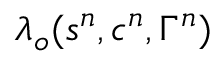Convert formula to latex. <formula><loc_0><loc_0><loc_500><loc_500>{ \lambda } _ { o } ( s ^ { n } , c ^ { n } , \Gamma ^ { n } )</formula> 